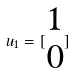Convert formula to latex. <formula><loc_0><loc_0><loc_500><loc_500>u _ { 1 } = [ \begin{matrix} 1 \\ 0 \end{matrix} ]</formula> 